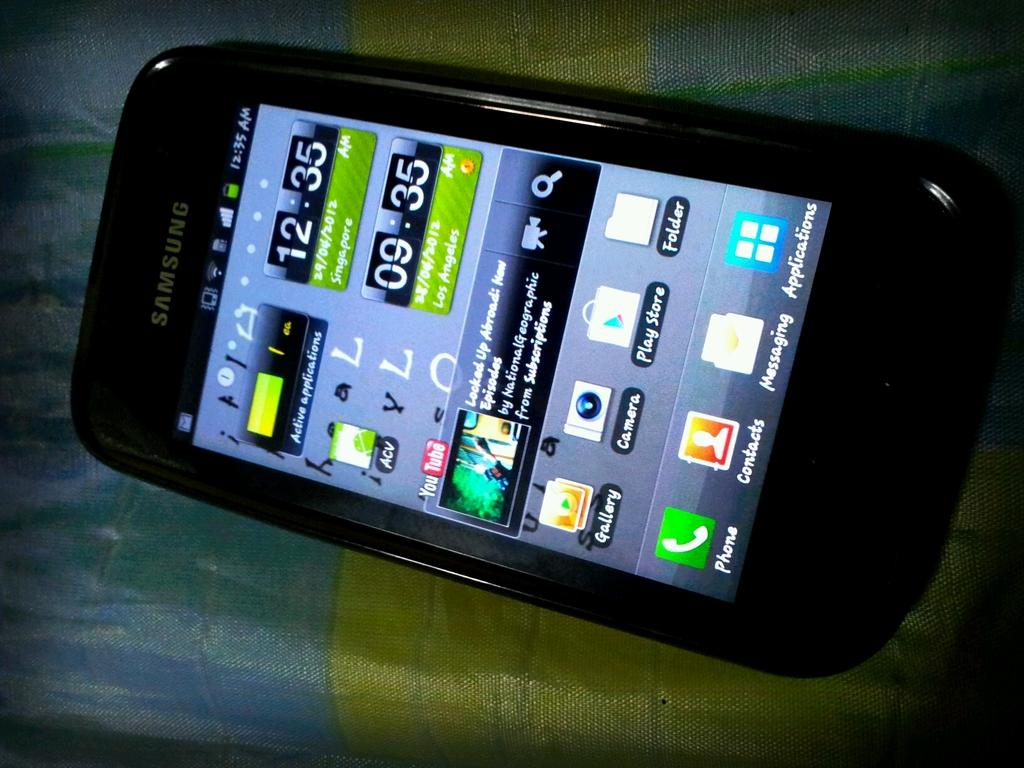Provide a one-sentence caption for the provided image. A phone includes an app called ACV, and a YouTube app. 